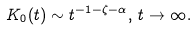<formula> <loc_0><loc_0><loc_500><loc_500>K _ { 0 } ( t ) \sim t ^ { - 1 - \zeta - \alpha } , \, t \rightarrow \infty .</formula> 